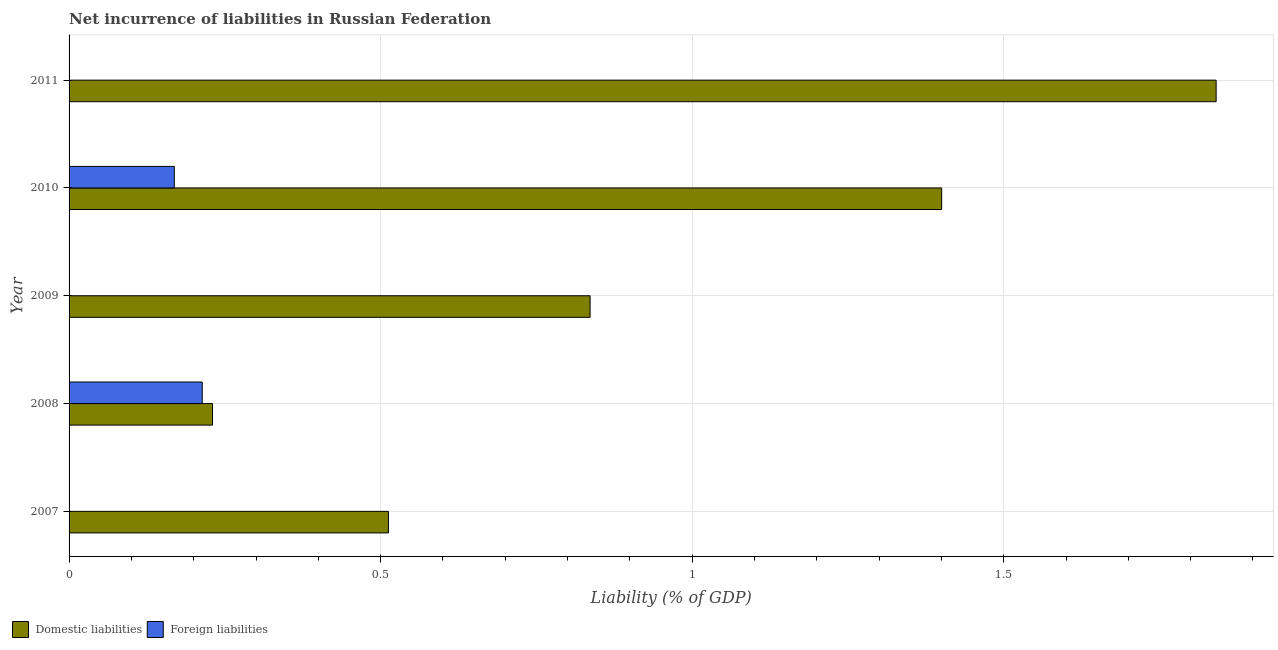Are the number of bars on each tick of the Y-axis equal?
Your response must be concise. No. How many bars are there on the 4th tick from the top?
Make the answer very short. 2. What is the incurrence of domestic liabilities in 2009?
Provide a short and direct response. 0.84. Across all years, what is the maximum incurrence of foreign liabilities?
Keep it short and to the point. 0.21. Across all years, what is the minimum incurrence of domestic liabilities?
Provide a succinct answer. 0.23. In which year was the incurrence of foreign liabilities maximum?
Make the answer very short. 2008. What is the total incurrence of domestic liabilities in the graph?
Keep it short and to the point. 4.82. What is the difference between the incurrence of domestic liabilities in 2008 and that in 2009?
Ensure brevity in your answer.  -0.61. What is the difference between the incurrence of domestic liabilities in 2011 and the incurrence of foreign liabilities in 2007?
Offer a very short reply. 1.84. What is the average incurrence of foreign liabilities per year?
Your answer should be very brief. 0.08. In the year 2008, what is the difference between the incurrence of domestic liabilities and incurrence of foreign liabilities?
Your answer should be compact. 0.02. What is the ratio of the incurrence of domestic liabilities in 2009 to that in 2010?
Make the answer very short. 0.6. What is the difference between the highest and the second highest incurrence of domestic liabilities?
Your answer should be compact. 0.44. What is the difference between the highest and the lowest incurrence of foreign liabilities?
Your answer should be compact. 0.21. Is the sum of the incurrence of domestic liabilities in 2007 and 2009 greater than the maximum incurrence of foreign liabilities across all years?
Provide a short and direct response. Yes. How many bars are there?
Keep it short and to the point. 7. Where does the legend appear in the graph?
Your response must be concise. Bottom left. What is the title of the graph?
Your response must be concise. Net incurrence of liabilities in Russian Federation. What is the label or title of the X-axis?
Give a very brief answer. Liability (% of GDP). What is the Liability (% of GDP) in Domestic liabilities in 2007?
Keep it short and to the point. 0.51. What is the Liability (% of GDP) of Foreign liabilities in 2007?
Offer a very short reply. 0. What is the Liability (% of GDP) in Domestic liabilities in 2008?
Offer a terse response. 0.23. What is the Liability (% of GDP) of Foreign liabilities in 2008?
Your response must be concise. 0.21. What is the Liability (% of GDP) of Domestic liabilities in 2009?
Offer a terse response. 0.84. What is the Liability (% of GDP) of Domestic liabilities in 2010?
Offer a very short reply. 1.4. What is the Liability (% of GDP) in Foreign liabilities in 2010?
Give a very brief answer. 0.17. What is the Liability (% of GDP) in Domestic liabilities in 2011?
Provide a succinct answer. 1.84. Across all years, what is the maximum Liability (% of GDP) of Domestic liabilities?
Your response must be concise. 1.84. Across all years, what is the maximum Liability (% of GDP) in Foreign liabilities?
Your answer should be very brief. 0.21. Across all years, what is the minimum Liability (% of GDP) of Domestic liabilities?
Your answer should be very brief. 0.23. What is the total Liability (% of GDP) of Domestic liabilities in the graph?
Give a very brief answer. 4.82. What is the total Liability (% of GDP) in Foreign liabilities in the graph?
Your answer should be very brief. 0.38. What is the difference between the Liability (% of GDP) of Domestic liabilities in 2007 and that in 2008?
Your response must be concise. 0.28. What is the difference between the Liability (% of GDP) of Domestic liabilities in 2007 and that in 2009?
Offer a very short reply. -0.32. What is the difference between the Liability (% of GDP) of Domestic liabilities in 2007 and that in 2010?
Provide a short and direct response. -0.89. What is the difference between the Liability (% of GDP) in Domestic liabilities in 2007 and that in 2011?
Provide a succinct answer. -1.33. What is the difference between the Liability (% of GDP) of Domestic liabilities in 2008 and that in 2009?
Provide a short and direct response. -0.61. What is the difference between the Liability (% of GDP) of Domestic liabilities in 2008 and that in 2010?
Provide a succinct answer. -1.17. What is the difference between the Liability (% of GDP) in Foreign liabilities in 2008 and that in 2010?
Make the answer very short. 0.04. What is the difference between the Liability (% of GDP) in Domestic liabilities in 2008 and that in 2011?
Give a very brief answer. -1.61. What is the difference between the Liability (% of GDP) in Domestic liabilities in 2009 and that in 2010?
Your response must be concise. -0.56. What is the difference between the Liability (% of GDP) of Domestic liabilities in 2009 and that in 2011?
Your answer should be very brief. -1. What is the difference between the Liability (% of GDP) in Domestic liabilities in 2010 and that in 2011?
Give a very brief answer. -0.44. What is the difference between the Liability (% of GDP) of Domestic liabilities in 2007 and the Liability (% of GDP) of Foreign liabilities in 2008?
Make the answer very short. 0.3. What is the difference between the Liability (% of GDP) of Domestic liabilities in 2007 and the Liability (% of GDP) of Foreign liabilities in 2010?
Provide a succinct answer. 0.34. What is the difference between the Liability (% of GDP) in Domestic liabilities in 2008 and the Liability (% of GDP) in Foreign liabilities in 2010?
Your answer should be compact. 0.06. What is the difference between the Liability (% of GDP) of Domestic liabilities in 2009 and the Liability (% of GDP) of Foreign liabilities in 2010?
Make the answer very short. 0.67. What is the average Liability (% of GDP) in Foreign liabilities per year?
Offer a terse response. 0.08. In the year 2008, what is the difference between the Liability (% of GDP) of Domestic liabilities and Liability (% of GDP) of Foreign liabilities?
Your answer should be compact. 0.02. In the year 2010, what is the difference between the Liability (% of GDP) of Domestic liabilities and Liability (% of GDP) of Foreign liabilities?
Ensure brevity in your answer.  1.23. What is the ratio of the Liability (% of GDP) of Domestic liabilities in 2007 to that in 2008?
Make the answer very short. 2.23. What is the ratio of the Liability (% of GDP) in Domestic liabilities in 2007 to that in 2009?
Keep it short and to the point. 0.61. What is the ratio of the Liability (% of GDP) of Domestic liabilities in 2007 to that in 2010?
Your answer should be very brief. 0.37. What is the ratio of the Liability (% of GDP) of Domestic liabilities in 2007 to that in 2011?
Your answer should be very brief. 0.28. What is the ratio of the Liability (% of GDP) in Domestic liabilities in 2008 to that in 2009?
Your answer should be compact. 0.28. What is the ratio of the Liability (% of GDP) in Domestic liabilities in 2008 to that in 2010?
Your answer should be very brief. 0.16. What is the ratio of the Liability (% of GDP) in Foreign liabilities in 2008 to that in 2010?
Your answer should be very brief. 1.27. What is the ratio of the Liability (% of GDP) in Domestic liabilities in 2008 to that in 2011?
Offer a terse response. 0.12. What is the ratio of the Liability (% of GDP) in Domestic liabilities in 2009 to that in 2010?
Your response must be concise. 0.6. What is the ratio of the Liability (% of GDP) in Domestic liabilities in 2009 to that in 2011?
Provide a succinct answer. 0.45. What is the ratio of the Liability (% of GDP) in Domestic liabilities in 2010 to that in 2011?
Provide a succinct answer. 0.76. What is the difference between the highest and the second highest Liability (% of GDP) of Domestic liabilities?
Provide a succinct answer. 0.44. What is the difference between the highest and the lowest Liability (% of GDP) of Domestic liabilities?
Ensure brevity in your answer.  1.61. What is the difference between the highest and the lowest Liability (% of GDP) of Foreign liabilities?
Your response must be concise. 0.21. 